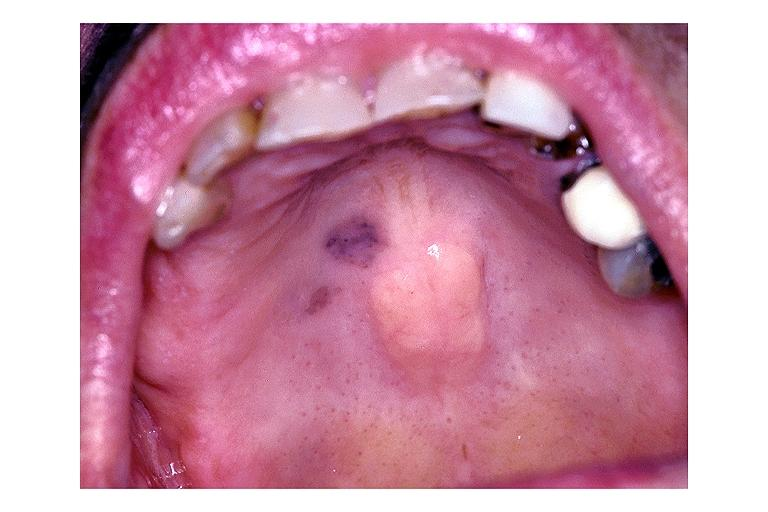where is this?
Answer the question using a single word or phrase. Oral 